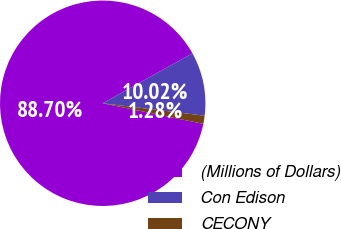Convert chart to OTSL. <chart><loc_0><loc_0><loc_500><loc_500><pie_chart><fcel>(Millions of Dollars)<fcel>Con Edison<fcel>CECONY<nl><fcel>88.7%<fcel>10.02%<fcel>1.28%<nl></chart> 